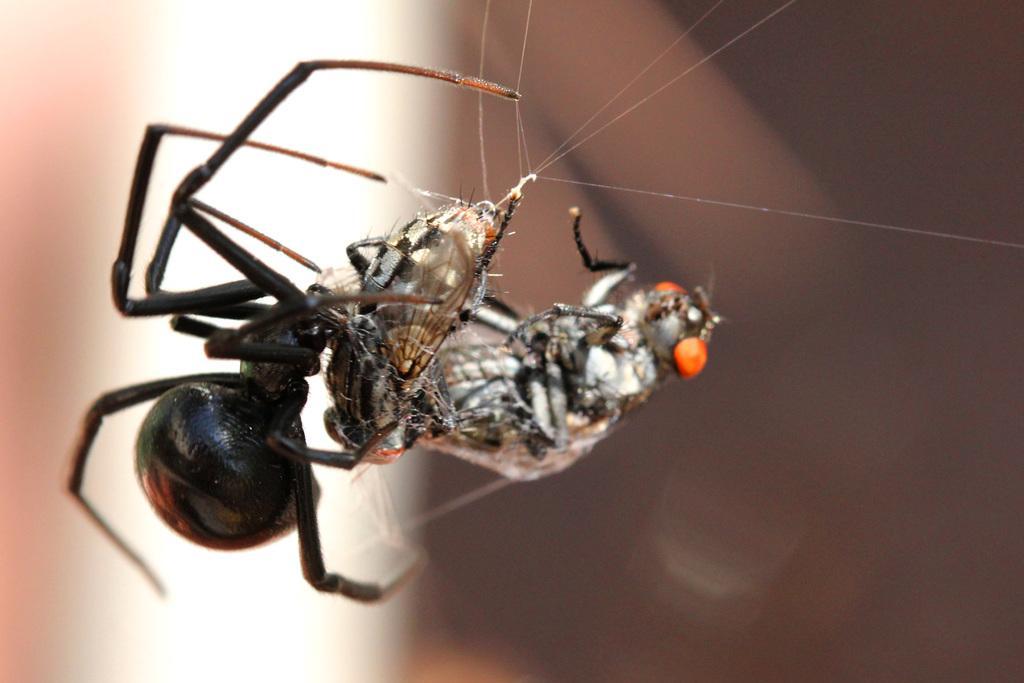In one or two sentences, can you explain what this image depicts? There are 2 spiders and there is a web. The background is blurred. 